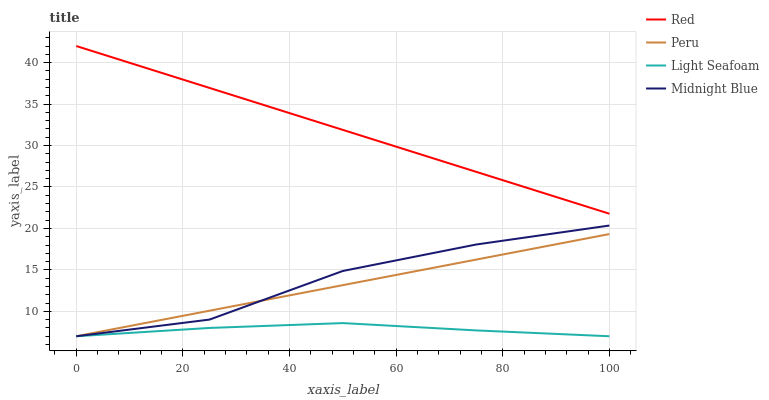Does Light Seafoam have the minimum area under the curve?
Answer yes or no. Yes. Does Red have the maximum area under the curve?
Answer yes or no. Yes. Does Peru have the minimum area under the curve?
Answer yes or no. No. Does Peru have the maximum area under the curve?
Answer yes or no. No. Is Peru the smoothest?
Answer yes or no. Yes. Is Midnight Blue the roughest?
Answer yes or no. Yes. Is Red the smoothest?
Answer yes or no. No. Is Red the roughest?
Answer yes or no. No. Does Light Seafoam have the lowest value?
Answer yes or no. Yes. Does Red have the lowest value?
Answer yes or no. No. Does Red have the highest value?
Answer yes or no. Yes. Does Peru have the highest value?
Answer yes or no. No. Is Midnight Blue less than Red?
Answer yes or no. Yes. Is Red greater than Light Seafoam?
Answer yes or no. Yes. Does Peru intersect Midnight Blue?
Answer yes or no. Yes. Is Peru less than Midnight Blue?
Answer yes or no. No. Is Peru greater than Midnight Blue?
Answer yes or no. No. Does Midnight Blue intersect Red?
Answer yes or no. No. 